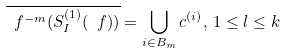Convert formula to latex. <formula><loc_0><loc_0><loc_500><loc_500>\overline { \ f ^ { - m } ( S _ { I } ^ { ( 1 ) } ( \ f ) ) } = \bigcup _ { i \in B _ { m } } \L c ^ { ( i ) } , \, 1 \leq l \leq k</formula> 